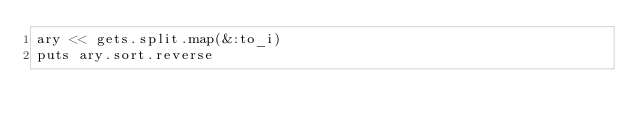<code> <loc_0><loc_0><loc_500><loc_500><_Ruby_>ary << gets.split.map(&:to_i)
puts ary.sort.reverse</code> 